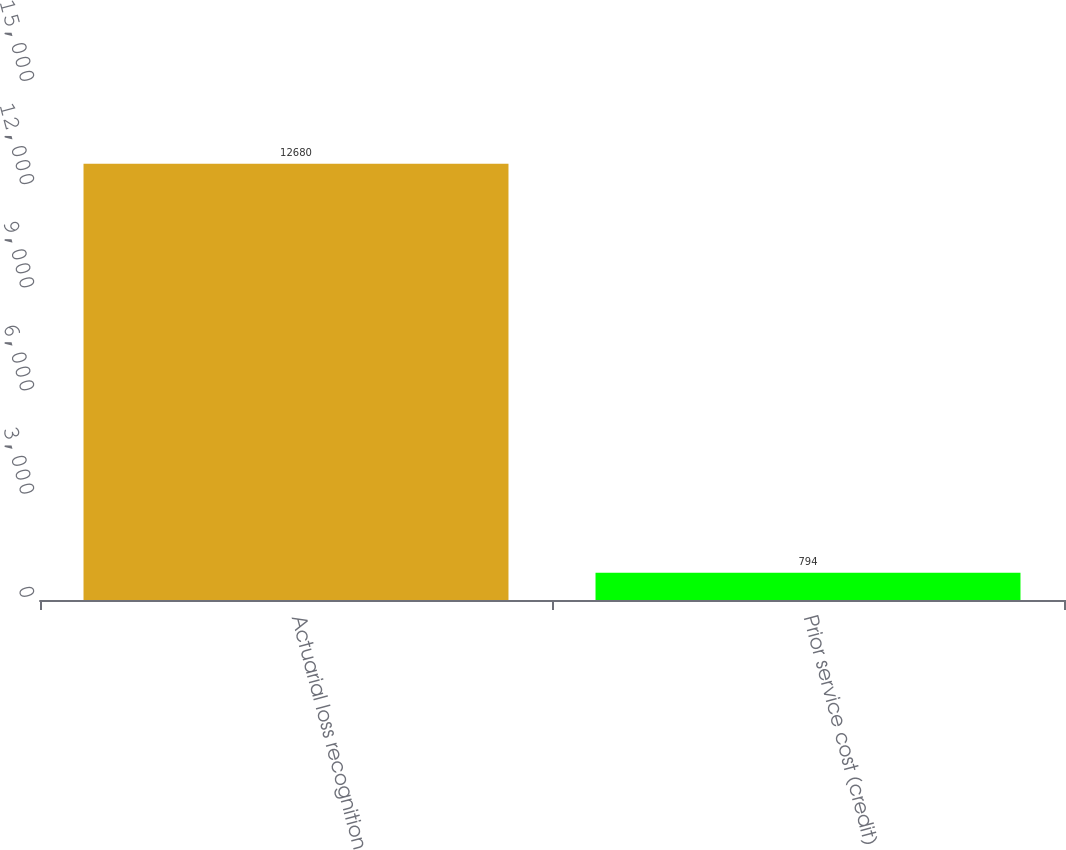Convert chart to OTSL. <chart><loc_0><loc_0><loc_500><loc_500><bar_chart><fcel>Actuarial loss recognition<fcel>Prior service cost (credit)<nl><fcel>12680<fcel>794<nl></chart> 